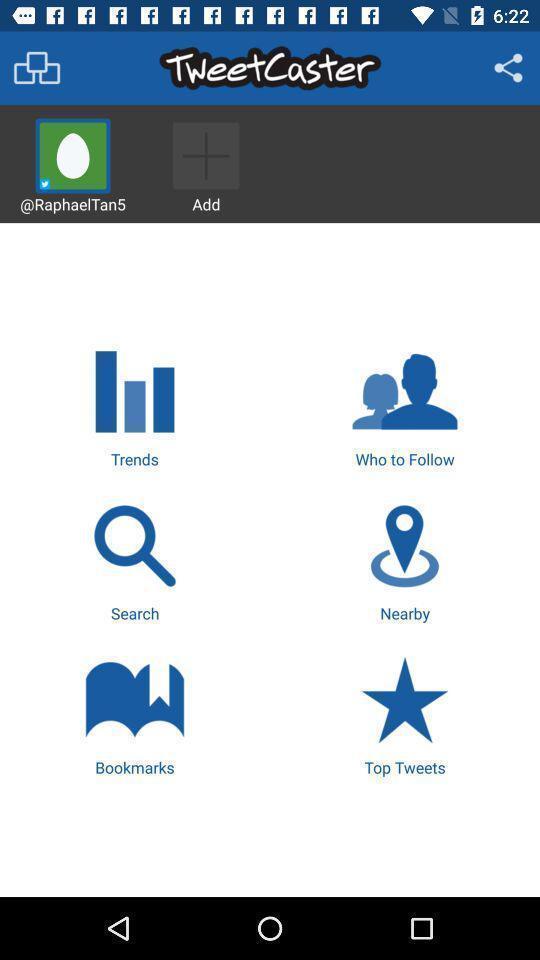What can you discern from this picture? Screen shows different options in a social app. 